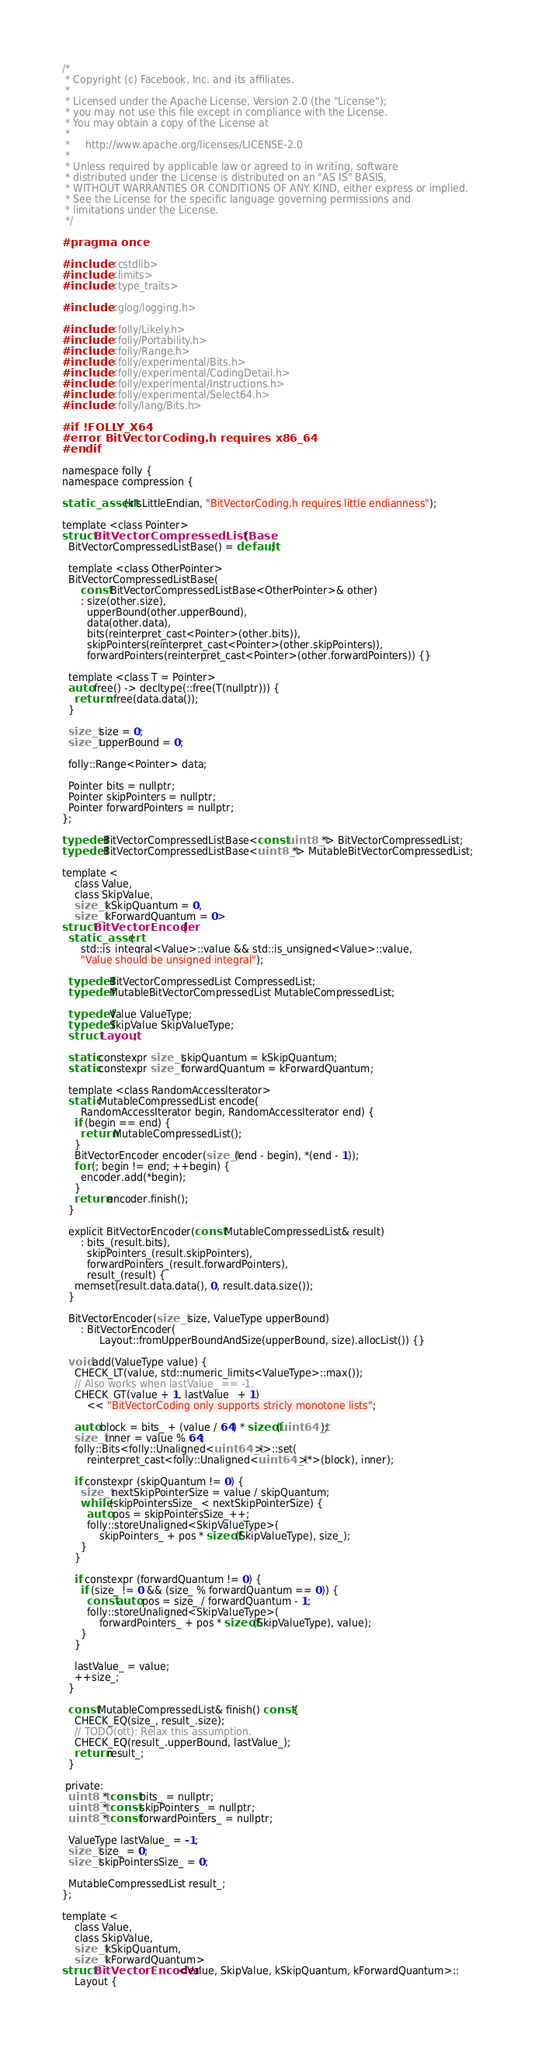Convert code to text. <code><loc_0><loc_0><loc_500><loc_500><_C_>/*
 * Copyright (c) Facebook, Inc. and its affiliates.
 *
 * Licensed under the Apache License, Version 2.0 (the "License");
 * you may not use this file except in compliance with the License.
 * You may obtain a copy of the License at
 *
 *     http://www.apache.org/licenses/LICENSE-2.0
 *
 * Unless required by applicable law or agreed to in writing, software
 * distributed under the License is distributed on an "AS IS" BASIS,
 * WITHOUT WARRANTIES OR CONDITIONS OF ANY KIND, either express or implied.
 * See the License for the specific language governing permissions and
 * limitations under the License.
 */

#pragma once

#include <cstdlib>
#include <limits>
#include <type_traits>

#include <glog/logging.h>

#include <folly/Likely.h>
#include <folly/Portability.h>
#include <folly/Range.h>
#include <folly/experimental/Bits.h>
#include <folly/experimental/CodingDetail.h>
#include <folly/experimental/Instructions.h>
#include <folly/experimental/Select64.h>
#include <folly/lang/Bits.h>

#if !FOLLY_X64
#error BitVectorCoding.h requires x86_64
#endif

namespace folly {
namespace compression {

static_assert(kIsLittleEndian, "BitVectorCoding.h requires little endianness");

template <class Pointer>
struct BitVectorCompressedListBase {
  BitVectorCompressedListBase() = default;

  template <class OtherPointer>
  BitVectorCompressedListBase(
      const BitVectorCompressedListBase<OtherPointer>& other)
      : size(other.size),
        upperBound(other.upperBound),
        data(other.data),
        bits(reinterpret_cast<Pointer>(other.bits)),
        skipPointers(reinterpret_cast<Pointer>(other.skipPointers)),
        forwardPointers(reinterpret_cast<Pointer>(other.forwardPointers)) {}

  template <class T = Pointer>
  auto free() -> decltype(::free(T(nullptr))) {
    return ::free(data.data());
  }

  size_t size = 0;
  size_t upperBound = 0;

  folly::Range<Pointer> data;

  Pointer bits = nullptr;
  Pointer skipPointers = nullptr;
  Pointer forwardPointers = nullptr;
};

typedef BitVectorCompressedListBase<const uint8_t*> BitVectorCompressedList;
typedef BitVectorCompressedListBase<uint8_t*> MutableBitVectorCompressedList;

template <
    class Value,
    class SkipValue,
    size_t kSkipQuantum = 0,
    size_t kForwardQuantum = 0>
struct BitVectorEncoder {
  static_assert(
      std::is_integral<Value>::value && std::is_unsigned<Value>::value,
      "Value should be unsigned integral");

  typedef BitVectorCompressedList CompressedList;
  typedef MutableBitVectorCompressedList MutableCompressedList;

  typedef Value ValueType;
  typedef SkipValue SkipValueType;
  struct Layout;

  static constexpr size_t skipQuantum = kSkipQuantum;
  static constexpr size_t forwardQuantum = kForwardQuantum;

  template <class RandomAccessIterator>
  static MutableCompressedList encode(
      RandomAccessIterator begin, RandomAccessIterator end) {
    if (begin == end) {
      return MutableCompressedList();
    }
    BitVectorEncoder encoder(size_t(end - begin), *(end - 1));
    for (; begin != end; ++begin) {
      encoder.add(*begin);
    }
    return encoder.finish();
  }

  explicit BitVectorEncoder(const MutableCompressedList& result)
      : bits_(result.bits),
        skipPointers_(result.skipPointers),
        forwardPointers_(result.forwardPointers),
        result_(result) {
    memset(result.data.data(), 0, result.data.size());
  }

  BitVectorEncoder(size_t size, ValueType upperBound)
      : BitVectorEncoder(
            Layout::fromUpperBoundAndSize(upperBound, size).allocList()) {}

  void add(ValueType value) {
    CHECK_LT(value, std::numeric_limits<ValueType>::max());
    // Also works when lastValue_ == -1.
    CHECK_GT(value + 1, lastValue_ + 1)
        << "BitVectorCoding only supports stricly monotone lists";

    auto block = bits_ + (value / 64) * sizeof(uint64_t);
    size_t inner = value % 64;
    folly::Bits<folly::Unaligned<uint64_t>>::set(
        reinterpret_cast<folly::Unaligned<uint64_t>*>(block), inner);

    if constexpr (skipQuantum != 0) {
      size_t nextSkipPointerSize = value / skipQuantum;
      while (skipPointersSize_ < nextSkipPointerSize) {
        auto pos = skipPointersSize_++;
        folly::storeUnaligned<SkipValueType>(
            skipPointers_ + pos * sizeof(SkipValueType), size_);
      }
    }

    if constexpr (forwardQuantum != 0) {
      if (size_ != 0 && (size_ % forwardQuantum == 0)) {
        const auto pos = size_ / forwardQuantum - 1;
        folly::storeUnaligned<SkipValueType>(
            forwardPointers_ + pos * sizeof(SkipValueType), value);
      }
    }

    lastValue_ = value;
    ++size_;
  }

  const MutableCompressedList& finish() const {
    CHECK_EQ(size_, result_.size);
    // TODO(ott): Relax this assumption.
    CHECK_EQ(result_.upperBound, lastValue_);
    return result_;
  }

 private:
  uint8_t* const bits_ = nullptr;
  uint8_t* const skipPointers_ = nullptr;
  uint8_t* const forwardPointers_ = nullptr;

  ValueType lastValue_ = -1;
  size_t size_ = 0;
  size_t skipPointersSize_ = 0;

  MutableCompressedList result_;
};

template <
    class Value,
    class SkipValue,
    size_t kSkipQuantum,
    size_t kForwardQuantum>
struct BitVectorEncoder<Value, SkipValue, kSkipQuantum, kForwardQuantum>::
    Layout {</code> 